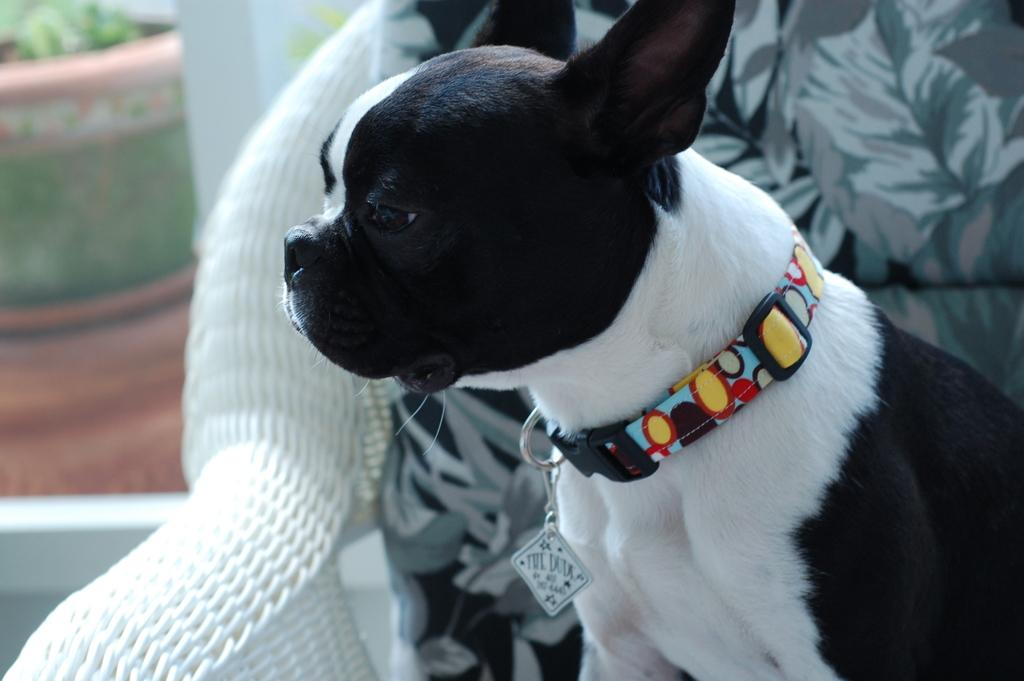What animal is present in the image? There is a dog in the image. Where is the dog located? The dog is on a chair. Can you describe the appearance of the left side of the image? The left side of the image is blurred. How many babies are visible in the image? There are no babies present in the image; it features a dog on a chair. What type of bat is flying in the image? There is no bat present in the image. 